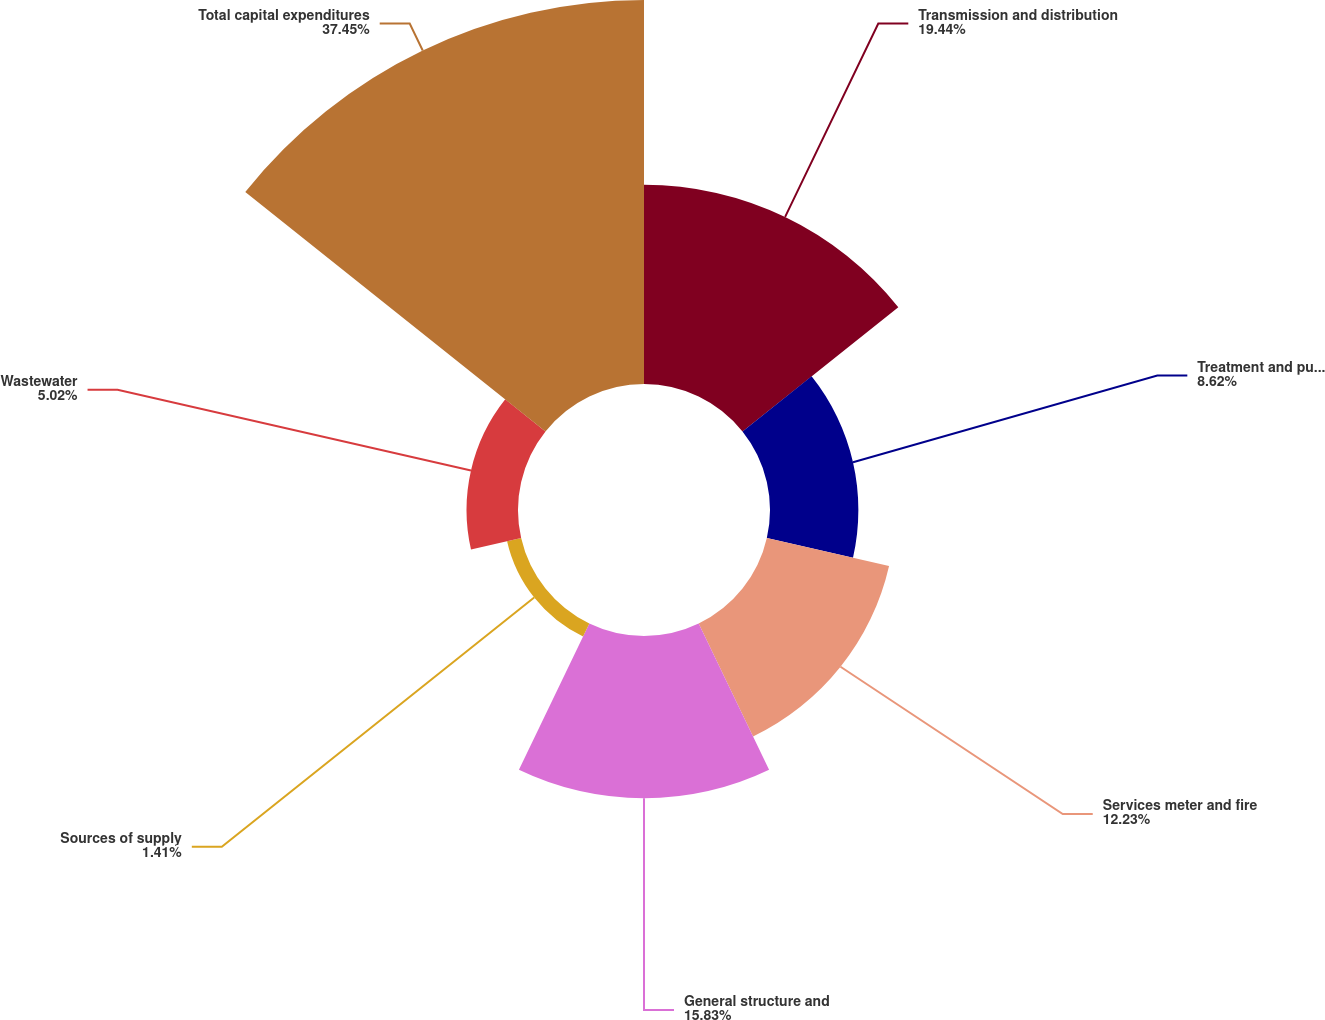<chart> <loc_0><loc_0><loc_500><loc_500><pie_chart><fcel>Transmission and distribution<fcel>Treatment and pumping<fcel>Services meter and fire<fcel>General structure and<fcel>Sources of supply<fcel>Wastewater<fcel>Total capital expenditures<nl><fcel>19.44%<fcel>8.62%<fcel>12.23%<fcel>15.83%<fcel>1.41%<fcel>5.02%<fcel>37.46%<nl></chart> 